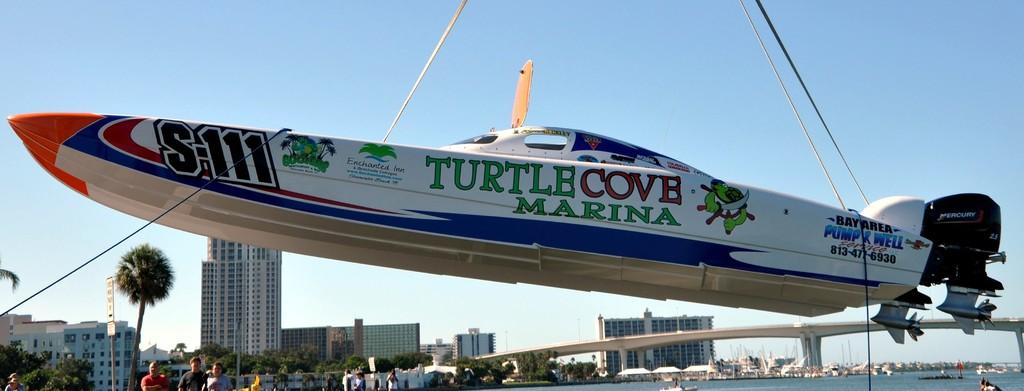What words are on the boat?
Make the answer very short. Turtle cove marina. 